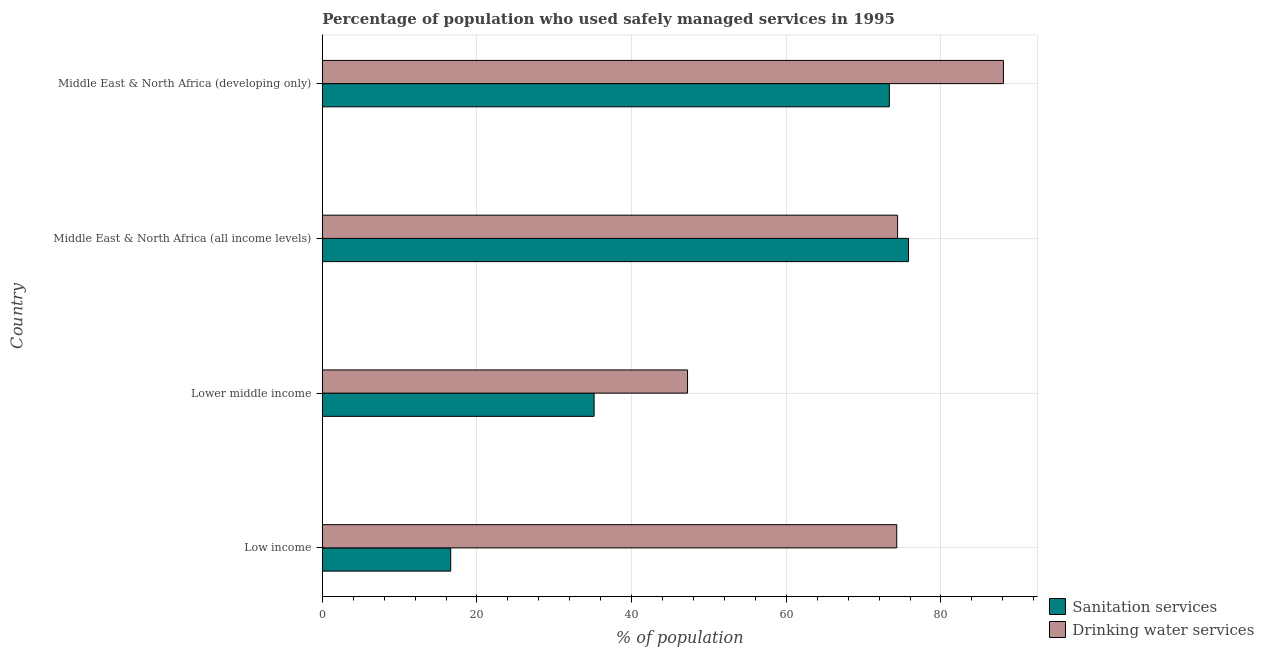How many different coloured bars are there?
Offer a very short reply. 2. How many groups of bars are there?
Provide a short and direct response. 4. Are the number of bars on each tick of the Y-axis equal?
Your answer should be very brief. Yes. How many bars are there on the 3rd tick from the bottom?
Your response must be concise. 2. What is the percentage of population who used sanitation services in Low income?
Offer a terse response. 16.6. Across all countries, what is the maximum percentage of population who used sanitation services?
Provide a short and direct response. 75.81. Across all countries, what is the minimum percentage of population who used drinking water services?
Your answer should be compact. 47.23. In which country was the percentage of population who used sanitation services maximum?
Your answer should be very brief. Middle East & North Africa (all income levels). What is the total percentage of population who used sanitation services in the graph?
Your answer should be compact. 200.88. What is the difference between the percentage of population who used sanitation services in Lower middle income and that in Middle East & North Africa (all income levels)?
Your answer should be very brief. -40.66. What is the difference between the percentage of population who used sanitation services in Lower middle income and the percentage of population who used drinking water services in Middle East & North Africa (developing only)?
Offer a terse response. -52.93. What is the average percentage of population who used drinking water services per country?
Provide a succinct answer. 71. What is the difference between the percentage of population who used drinking water services and percentage of population who used sanitation services in Lower middle income?
Offer a terse response. 12.09. What is the ratio of the percentage of population who used drinking water services in Low income to that in Middle East & North Africa (developing only)?
Your response must be concise. 0.84. Is the difference between the percentage of population who used sanitation services in Low income and Lower middle income greater than the difference between the percentage of population who used drinking water services in Low income and Lower middle income?
Ensure brevity in your answer.  No. What is the difference between the highest and the second highest percentage of population who used drinking water services?
Keep it short and to the point. 13.69. What is the difference between the highest and the lowest percentage of population who used drinking water services?
Offer a terse response. 40.85. Is the sum of the percentage of population who used drinking water services in Low income and Middle East & North Africa (developing only) greater than the maximum percentage of population who used sanitation services across all countries?
Your response must be concise. Yes. What does the 1st bar from the top in Lower middle income represents?
Make the answer very short. Drinking water services. What does the 2nd bar from the bottom in Middle East & North Africa (developing only) represents?
Make the answer very short. Drinking water services. How many bars are there?
Offer a terse response. 8. How many countries are there in the graph?
Make the answer very short. 4. Does the graph contain any zero values?
Offer a terse response. No. How are the legend labels stacked?
Provide a short and direct response. Vertical. What is the title of the graph?
Your answer should be compact. Percentage of population who used safely managed services in 1995. Does "Private credit bureau" appear as one of the legend labels in the graph?
Provide a succinct answer. No. What is the label or title of the X-axis?
Your response must be concise. % of population. What is the % of population in Sanitation services in Low income?
Provide a succinct answer. 16.6. What is the % of population in Drinking water services in Low income?
Provide a succinct answer. 74.29. What is the % of population in Sanitation services in Lower middle income?
Provide a succinct answer. 35.14. What is the % of population in Drinking water services in Lower middle income?
Make the answer very short. 47.23. What is the % of population of Sanitation services in Middle East & North Africa (all income levels)?
Provide a succinct answer. 75.81. What is the % of population of Drinking water services in Middle East & North Africa (all income levels)?
Provide a short and direct response. 74.39. What is the % of population in Sanitation services in Middle East & North Africa (developing only)?
Ensure brevity in your answer.  73.33. What is the % of population of Drinking water services in Middle East & North Africa (developing only)?
Keep it short and to the point. 88.08. Across all countries, what is the maximum % of population of Sanitation services?
Offer a very short reply. 75.81. Across all countries, what is the maximum % of population in Drinking water services?
Your response must be concise. 88.08. Across all countries, what is the minimum % of population of Sanitation services?
Your response must be concise. 16.6. Across all countries, what is the minimum % of population in Drinking water services?
Provide a succinct answer. 47.23. What is the total % of population in Sanitation services in the graph?
Ensure brevity in your answer.  200.88. What is the total % of population of Drinking water services in the graph?
Provide a short and direct response. 283.99. What is the difference between the % of population of Sanitation services in Low income and that in Lower middle income?
Provide a succinct answer. -18.54. What is the difference between the % of population of Drinking water services in Low income and that in Lower middle income?
Make the answer very short. 27.06. What is the difference between the % of population of Sanitation services in Low income and that in Middle East & North Africa (all income levels)?
Your response must be concise. -59.2. What is the difference between the % of population of Drinking water services in Low income and that in Middle East & North Africa (all income levels)?
Provide a short and direct response. -0.11. What is the difference between the % of population in Sanitation services in Low income and that in Middle East & North Africa (developing only)?
Provide a succinct answer. -56.72. What is the difference between the % of population in Drinking water services in Low income and that in Middle East & North Africa (developing only)?
Ensure brevity in your answer.  -13.79. What is the difference between the % of population in Sanitation services in Lower middle income and that in Middle East & North Africa (all income levels)?
Give a very brief answer. -40.66. What is the difference between the % of population in Drinking water services in Lower middle income and that in Middle East & North Africa (all income levels)?
Make the answer very short. -27.16. What is the difference between the % of population of Sanitation services in Lower middle income and that in Middle East & North Africa (developing only)?
Offer a very short reply. -38.18. What is the difference between the % of population in Drinking water services in Lower middle income and that in Middle East & North Africa (developing only)?
Offer a terse response. -40.85. What is the difference between the % of population in Sanitation services in Middle East & North Africa (all income levels) and that in Middle East & North Africa (developing only)?
Make the answer very short. 2.48. What is the difference between the % of population of Drinking water services in Middle East & North Africa (all income levels) and that in Middle East & North Africa (developing only)?
Ensure brevity in your answer.  -13.68. What is the difference between the % of population of Sanitation services in Low income and the % of population of Drinking water services in Lower middle income?
Give a very brief answer. -30.63. What is the difference between the % of population of Sanitation services in Low income and the % of population of Drinking water services in Middle East & North Africa (all income levels)?
Keep it short and to the point. -57.79. What is the difference between the % of population of Sanitation services in Low income and the % of population of Drinking water services in Middle East & North Africa (developing only)?
Offer a very short reply. -71.48. What is the difference between the % of population in Sanitation services in Lower middle income and the % of population in Drinking water services in Middle East & North Africa (all income levels)?
Make the answer very short. -39.25. What is the difference between the % of population in Sanitation services in Lower middle income and the % of population in Drinking water services in Middle East & North Africa (developing only)?
Offer a very short reply. -52.93. What is the difference between the % of population in Sanitation services in Middle East & North Africa (all income levels) and the % of population in Drinking water services in Middle East & North Africa (developing only)?
Keep it short and to the point. -12.27. What is the average % of population in Sanitation services per country?
Make the answer very short. 50.22. What is the average % of population in Drinking water services per country?
Ensure brevity in your answer.  71. What is the difference between the % of population of Sanitation services and % of population of Drinking water services in Low income?
Ensure brevity in your answer.  -57.68. What is the difference between the % of population of Sanitation services and % of population of Drinking water services in Lower middle income?
Your answer should be compact. -12.09. What is the difference between the % of population in Sanitation services and % of population in Drinking water services in Middle East & North Africa (all income levels)?
Provide a succinct answer. 1.41. What is the difference between the % of population of Sanitation services and % of population of Drinking water services in Middle East & North Africa (developing only)?
Provide a short and direct response. -14.75. What is the ratio of the % of population of Sanitation services in Low income to that in Lower middle income?
Offer a terse response. 0.47. What is the ratio of the % of population in Drinking water services in Low income to that in Lower middle income?
Keep it short and to the point. 1.57. What is the ratio of the % of population of Sanitation services in Low income to that in Middle East & North Africa (all income levels)?
Ensure brevity in your answer.  0.22. What is the ratio of the % of population in Sanitation services in Low income to that in Middle East & North Africa (developing only)?
Ensure brevity in your answer.  0.23. What is the ratio of the % of population of Drinking water services in Low income to that in Middle East & North Africa (developing only)?
Give a very brief answer. 0.84. What is the ratio of the % of population in Sanitation services in Lower middle income to that in Middle East & North Africa (all income levels)?
Give a very brief answer. 0.46. What is the ratio of the % of population of Drinking water services in Lower middle income to that in Middle East & North Africa (all income levels)?
Your response must be concise. 0.63. What is the ratio of the % of population in Sanitation services in Lower middle income to that in Middle East & North Africa (developing only)?
Offer a terse response. 0.48. What is the ratio of the % of population of Drinking water services in Lower middle income to that in Middle East & North Africa (developing only)?
Offer a very short reply. 0.54. What is the ratio of the % of population in Sanitation services in Middle East & North Africa (all income levels) to that in Middle East & North Africa (developing only)?
Provide a short and direct response. 1.03. What is the ratio of the % of population in Drinking water services in Middle East & North Africa (all income levels) to that in Middle East & North Africa (developing only)?
Your answer should be compact. 0.84. What is the difference between the highest and the second highest % of population in Sanitation services?
Ensure brevity in your answer.  2.48. What is the difference between the highest and the second highest % of population of Drinking water services?
Your answer should be very brief. 13.68. What is the difference between the highest and the lowest % of population in Sanitation services?
Your answer should be compact. 59.2. What is the difference between the highest and the lowest % of population in Drinking water services?
Your answer should be very brief. 40.85. 